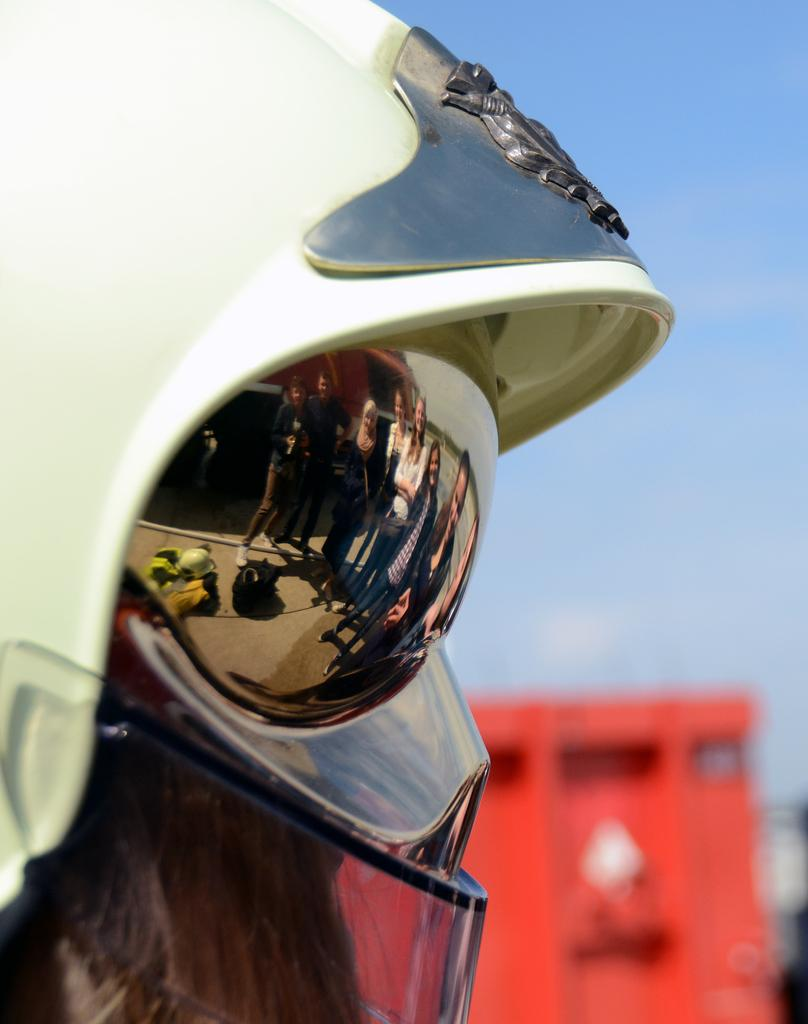What type of protective gear is visible in the image? There are goggles and a helmet in the image. Can you describe the color of any objects in the image? There is an object in red color in the image. What type of error can be seen in the image? There is no error present in the image. Can you tell me how many sons are visible in the image? There are no people, let alone sons, visible in the image. 